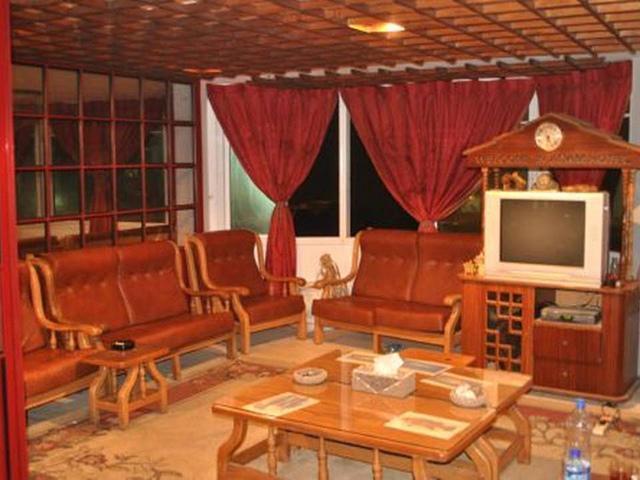How many couches can be seen?
Give a very brief answer. 2. How many chairs are visible?
Give a very brief answer. 2. 